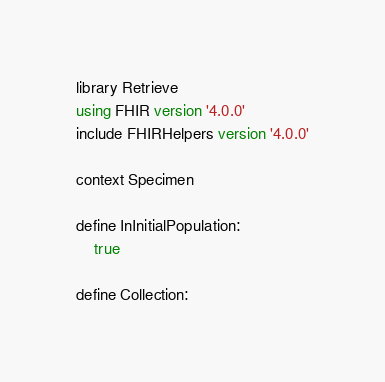<code> <loc_0><loc_0><loc_500><loc_500><_SQL_>library Retrieve
using FHIR version '4.0.0'
include FHIRHelpers version '4.0.0'

context Specimen

define InInitialPopulation:
    true

define Collection:</code> 